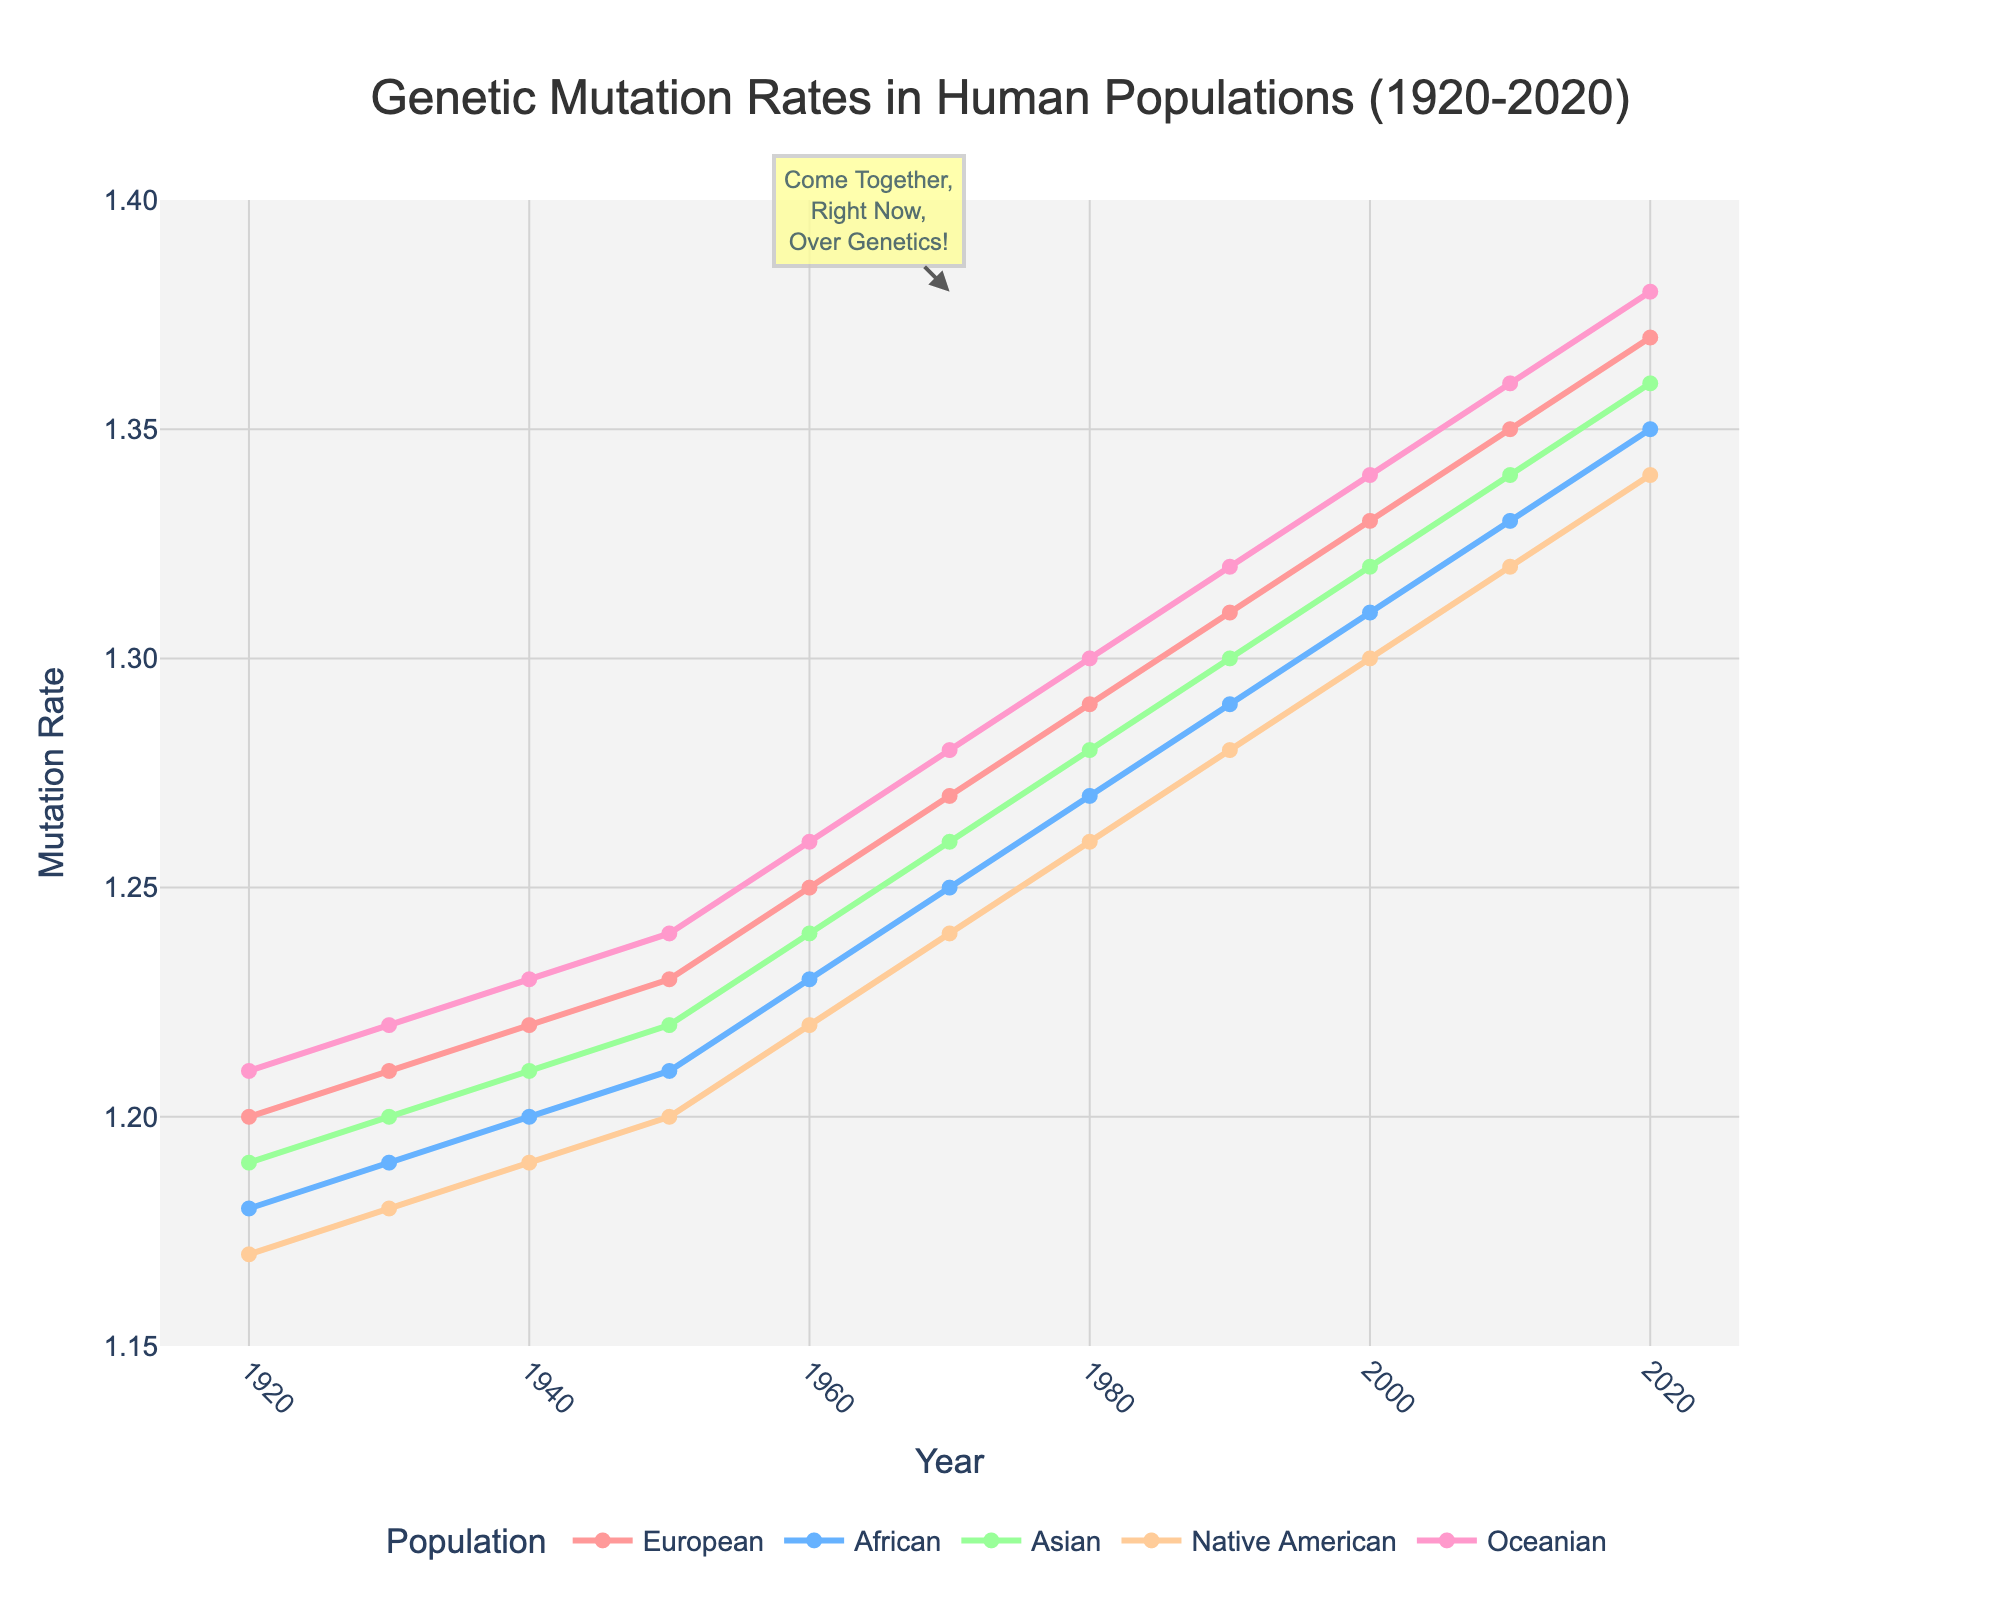What is the genetic mutation rate for Oceanian populations in 1960? Find the year 1960 on the x-axis, then follow vertically to the Oceanian line (pink). The y-axis will provide the mutation rate.
Answer: 1.26 Which population had the lowest mutation rate in 1980? Locate the year 1980 on the x-axis, then find the lowest data point among all the lines for that year. The Native American line (orange) is the lowest.
Answer: Native American Did the mutation rates of all populations increase or decrease over the century? Evaluate the trend for each population line from 1920 to 2020; all lines show an upward trend.
Answer: Increase Between the years 1950 and 1960, which population showed the highest increase in genetic mutation rate? Calculate the difference in mutation rates for each population between 1950 and 1960: European (0.02), African (0.02), Asian (0.02), Native American (0.02), Oceanian (0.02). All increases are 0.02, so none is highest.
Answer: None What is the average mutation rate for the European population from 1920 to 2020? Sum the mutation rates for the European population over the years and divide by the total number of years [(1.20+1.21+1.22+1.23+1.25+1.27+1.29+1.31+1.33+1.35+1.37)/11 = 1.275].
Answer: 1.275 Which population had the second highest genetic mutation rate in the year 2020? Identify the data points for 2020 and rank them: Oceanian (1.38), European (1.37), Asian (1.36), African (1.35), Native American (1.34). The second highest is European.
Answer: European What is the combined mutation rate of the African and Asian populations in 1940? Locate the mutation rates for the African (1.20) and Asian (1.21) populations in 1940 and sum them (1.20+1.21 = 2.41).
Answer: 2.41 During which decade did the mutation rate for the Native American population surpass 1.30? Track the Native American line (orange) and find when it crosses the 1.30 mark on the y-axis; it surpasses 1.30 between 2000 and 2010.
Answer: 2000-2010 Which population exhibits the steepest overall increase in mutation rates over the century? Assess the overall change (difference between 2020 and 1920 values) for each population: European (0.17), African (0.17), Asian (0.17), Native American (0.17), Oceanian (0.17). All are equal at 0.17.
Answer: All equal Is there any year where all populations had the same mutation rate? Review the lines for any year where all data points exactly overlap. None of the years show all populations having the same mutation rate.
Answer: No 